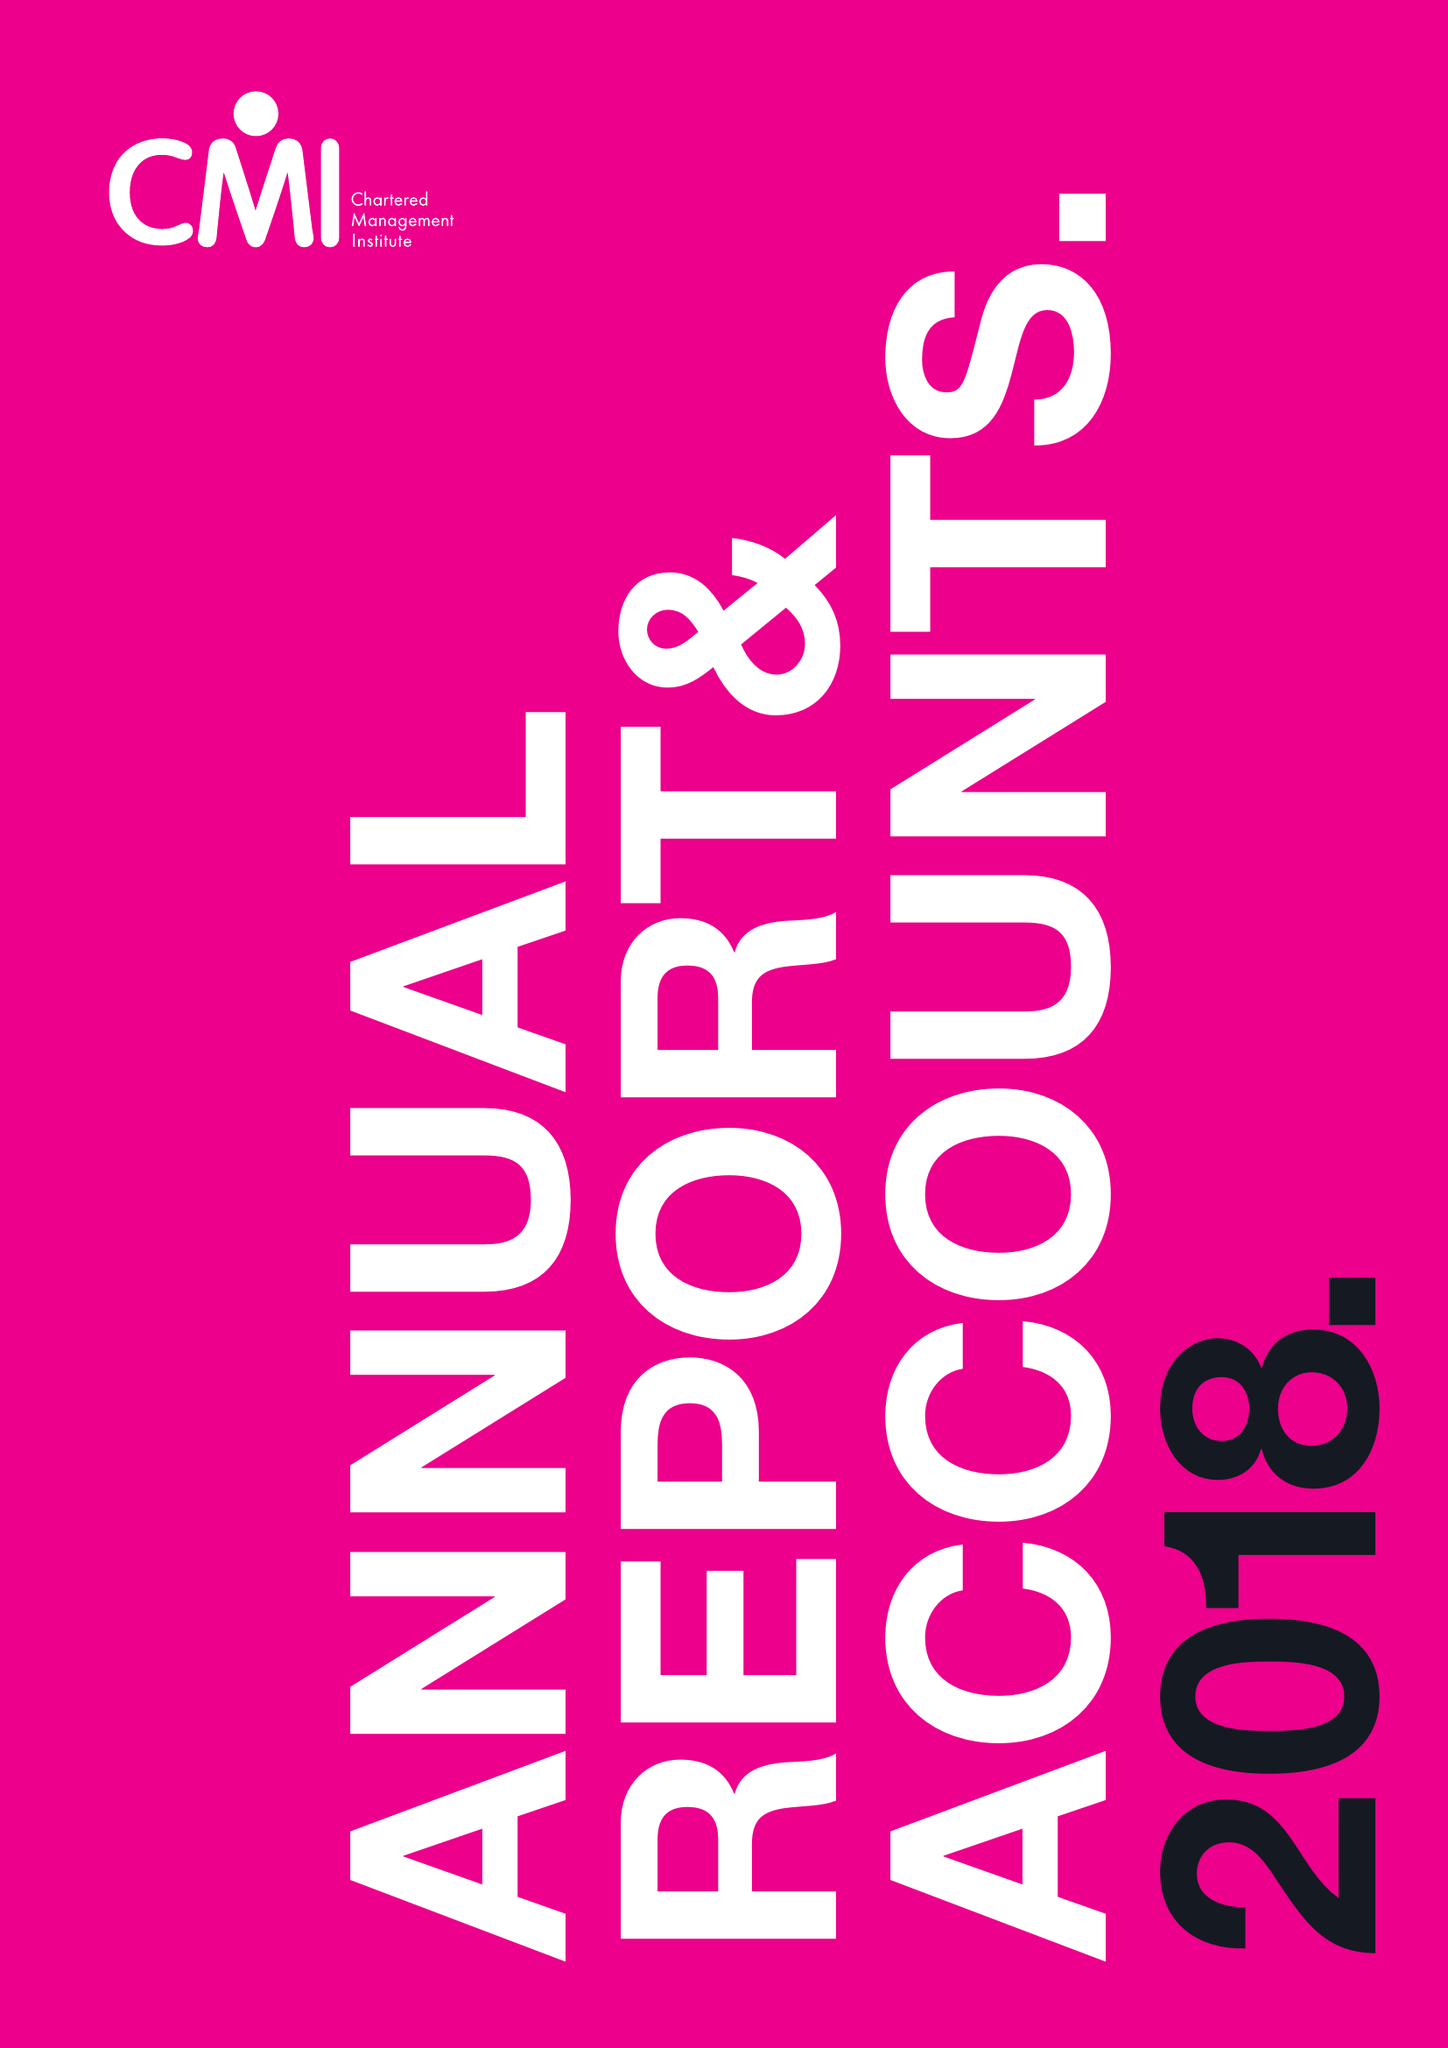What is the value for the address__postcode?
Answer the question using a single word or phrase. NN17 1TT 